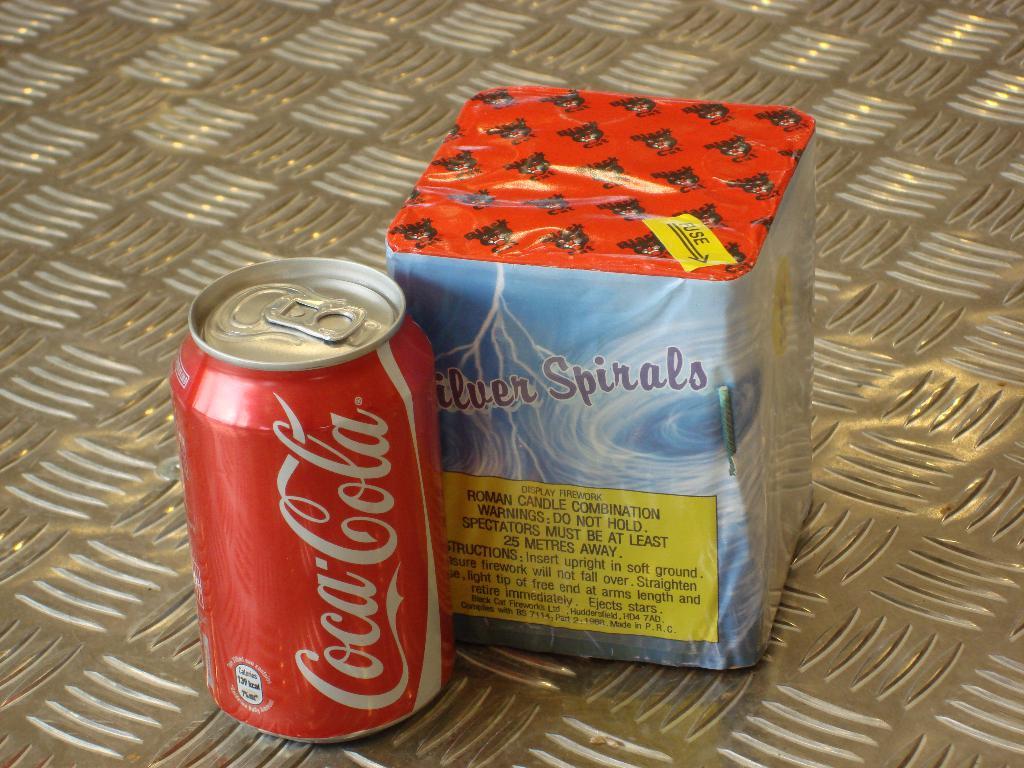What is the name of the firework shown?
Your answer should be very brief. Silver spirals. 